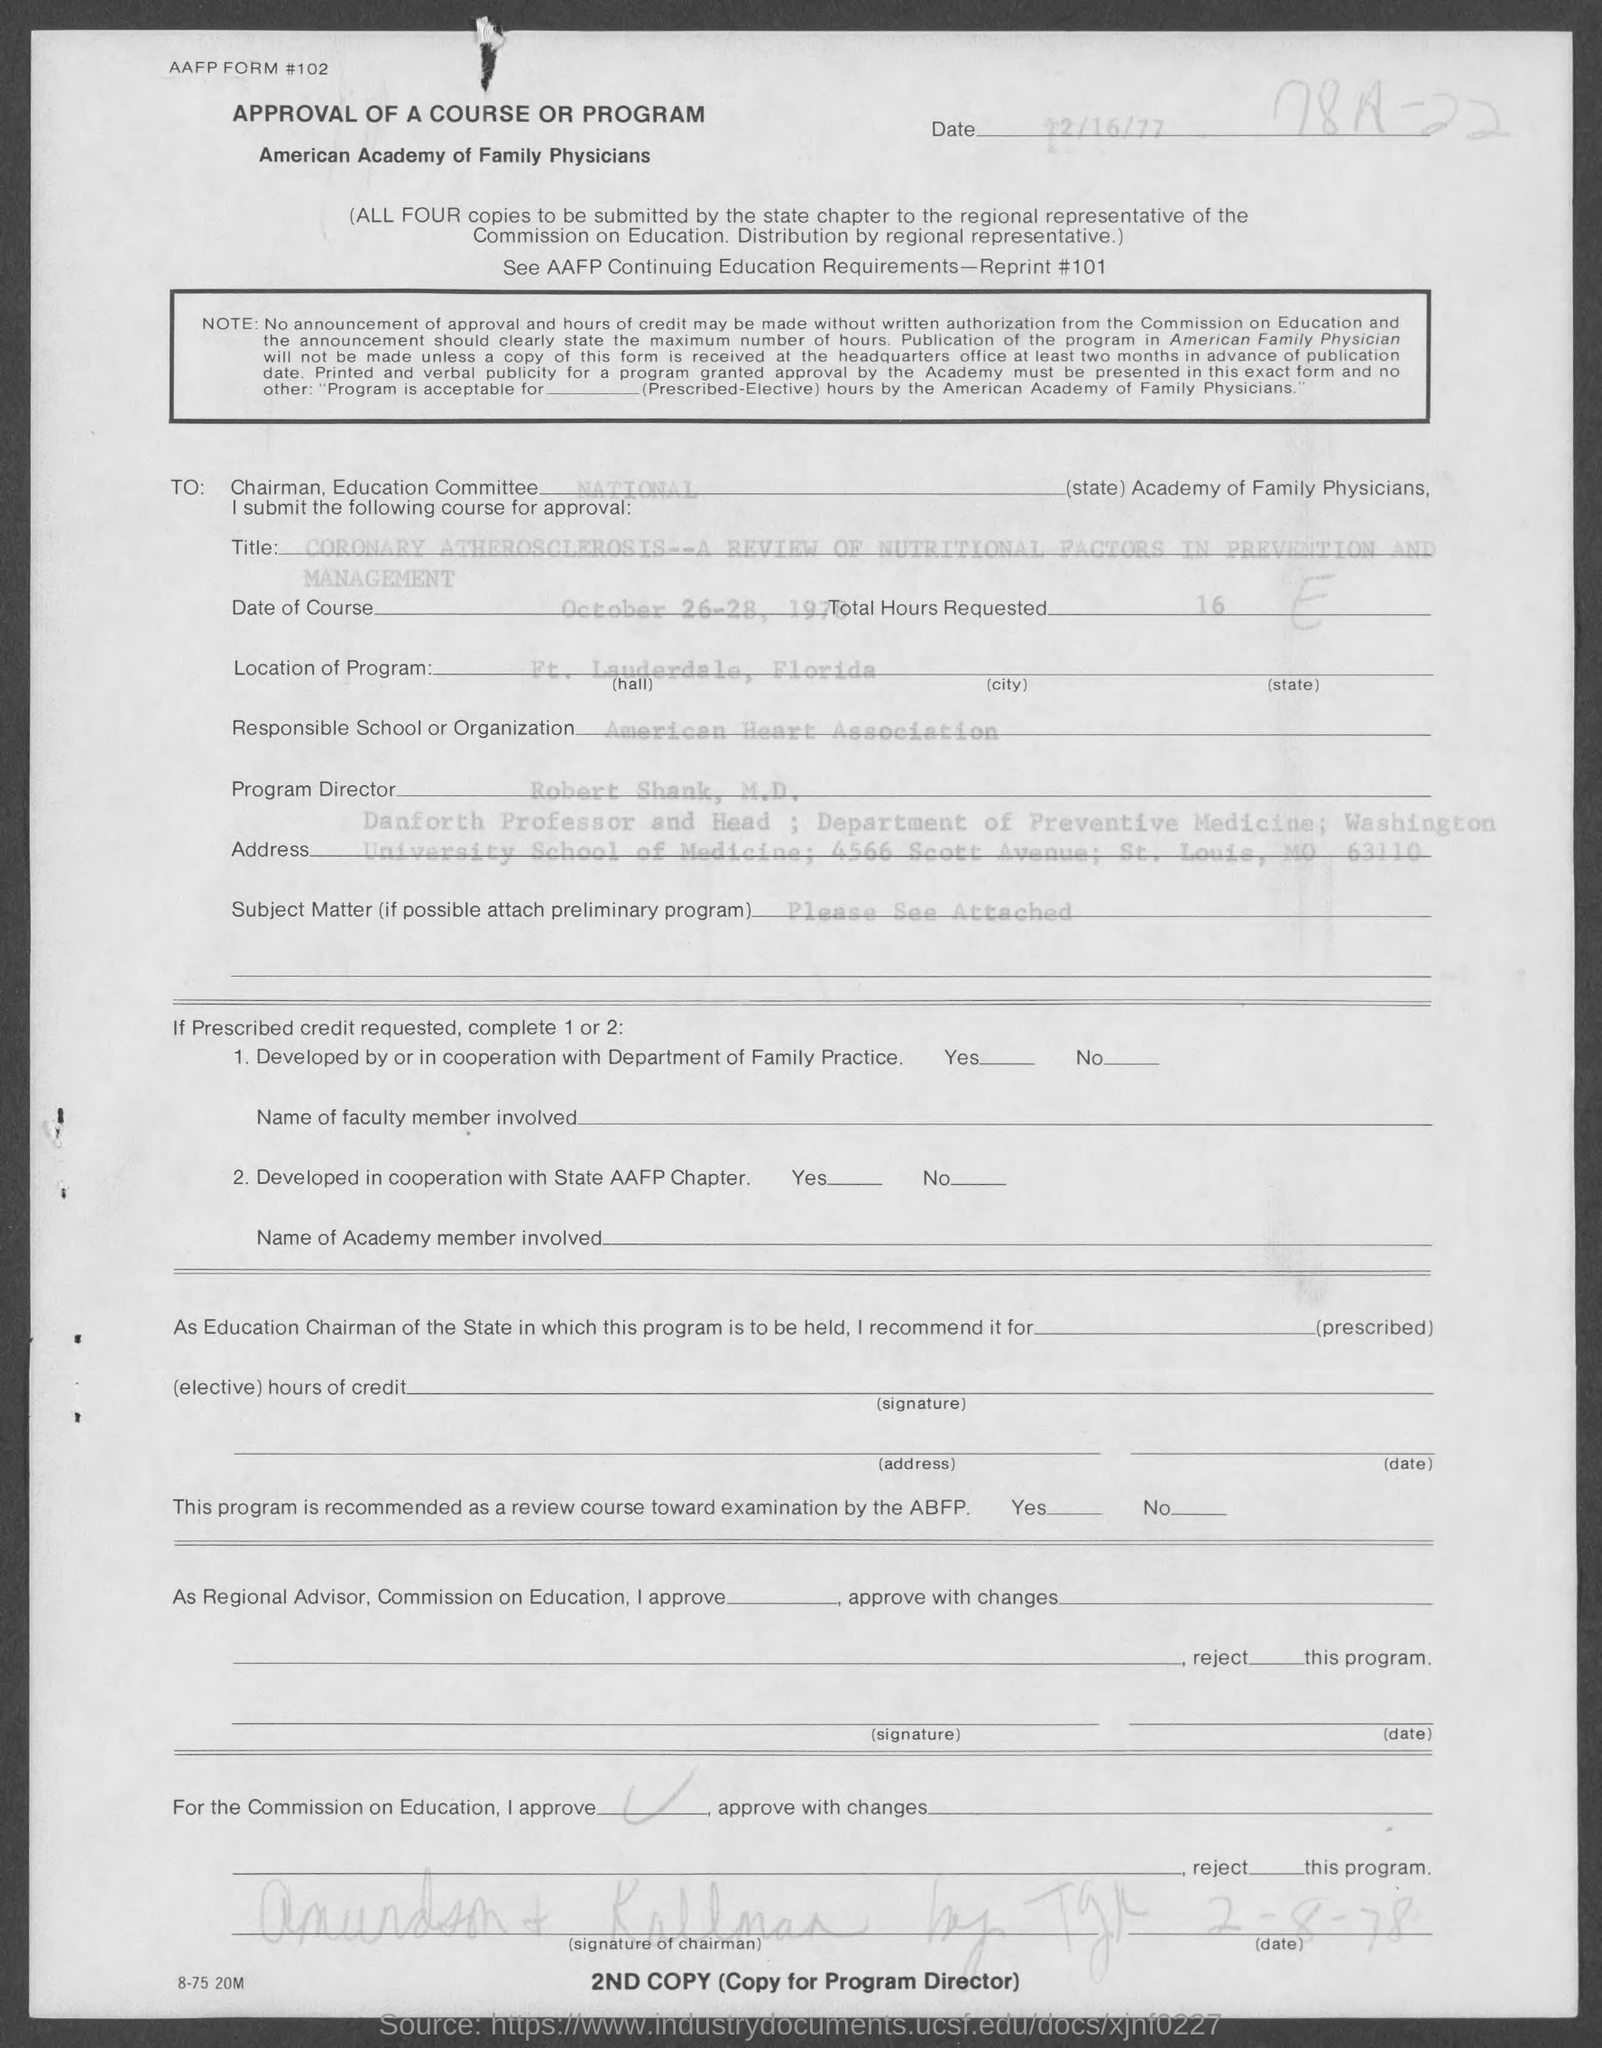Specify some key components in this picture. The program director is Robert Shank, M.D. The location of the program is in Ft. Lauderdale, Florida. The total hours requested are 16. The document was created on December 16th, 1977. The date of the course is October 26-28, 1978. 